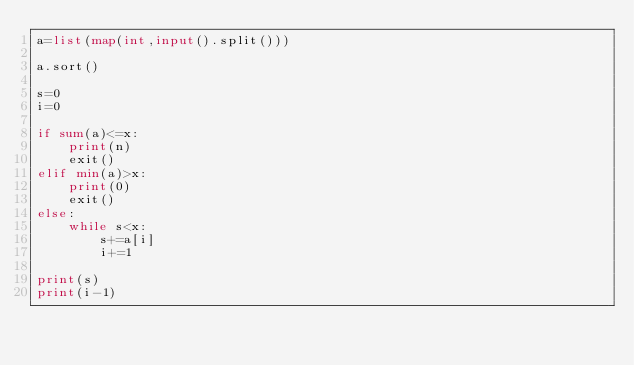<code> <loc_0><loc_0><loc_500><loc_500><_Python_>a=list(map(int,input().split()))

a.sort()

s=0
i=0

if sum(a)<=x:
    print(n)
    exit()
elif min(a)>x:
    print(0)
    exit()
else:
    while s<x:
        s+=a[i]
        i+=1

print(s)
print(i-1)</code> 